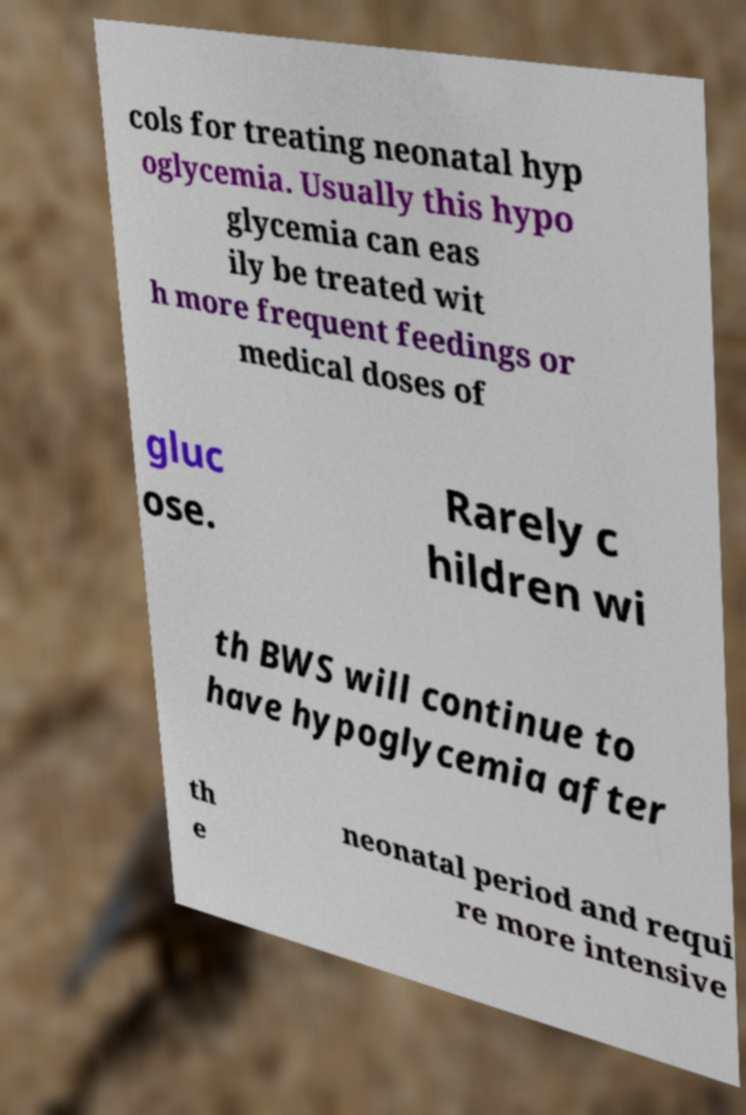What messages or text are displayed in this image? I need them in a readable, typed format. cols for treating neonatal hyp oglycemia. Usually this hypo glycemia can eas ily be treated wit h more frequent feedings or medical doses of gluc ose. Rarely c hildren wi th BWS will continue to have hypoglycemia after th e neonatal period and requi re more intensive 